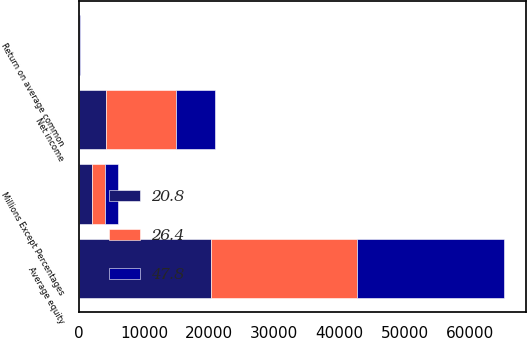Convert chart to OTSL. <chart><loc_0><loc_0><loc_500><loc_500><stacked_bar_chart><ecel><fcel>Millions Except Percentages<fcel>Net income<fcel>Average equity<fcel>Return on average common<nl><fcel>47.8<fcel>2018<fcel>5966<fcel>22640<fcel>26.4<nl><fcel>26.4<fcel>2017<fcel>10712<fcel>22394<fcel>47.8<nl><fcel>20.8<fcel>2016<fcel>4233<fcel>20317<fcel>20.8<nl></chart> 